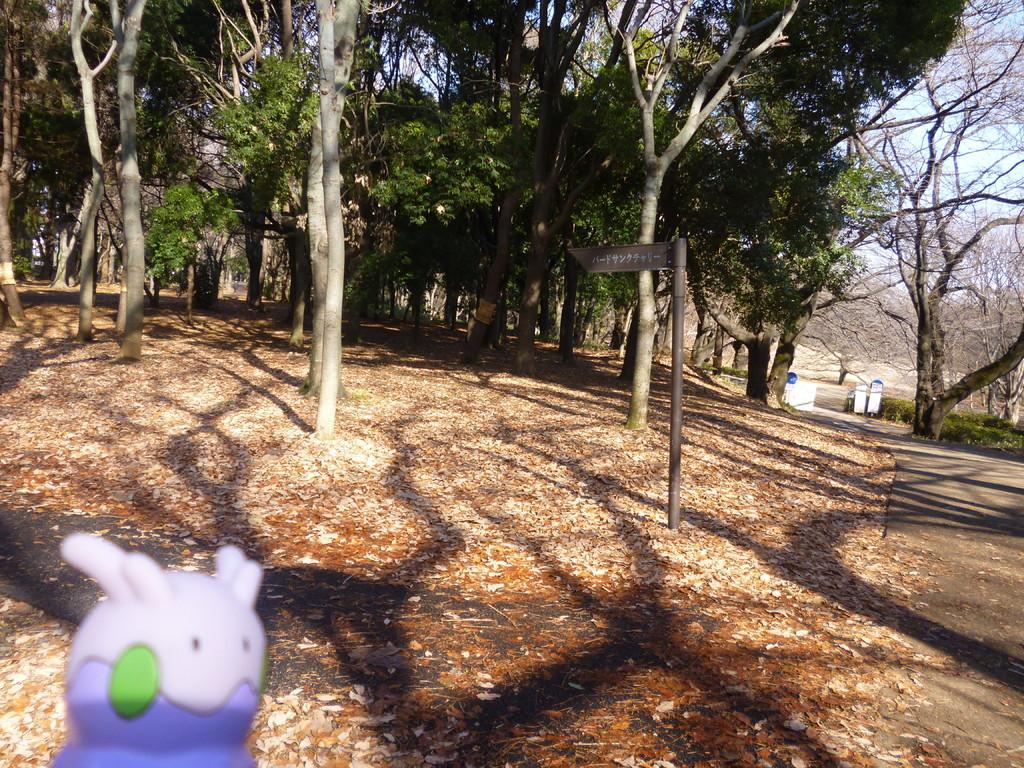Can you describe this image briefly? In this image we can see many trees. Image also consists of trash bins, rubber toy and also a pole. At the bottom we can see the dried leaves and also the road. 